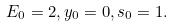Convert formula to latex. <formula><loc_0><loc_0><loc_500><loc_500>E _ { 0 } = 2 , y _ { 0 } = 0 , s _ { 0 } = 1 .</formula> 